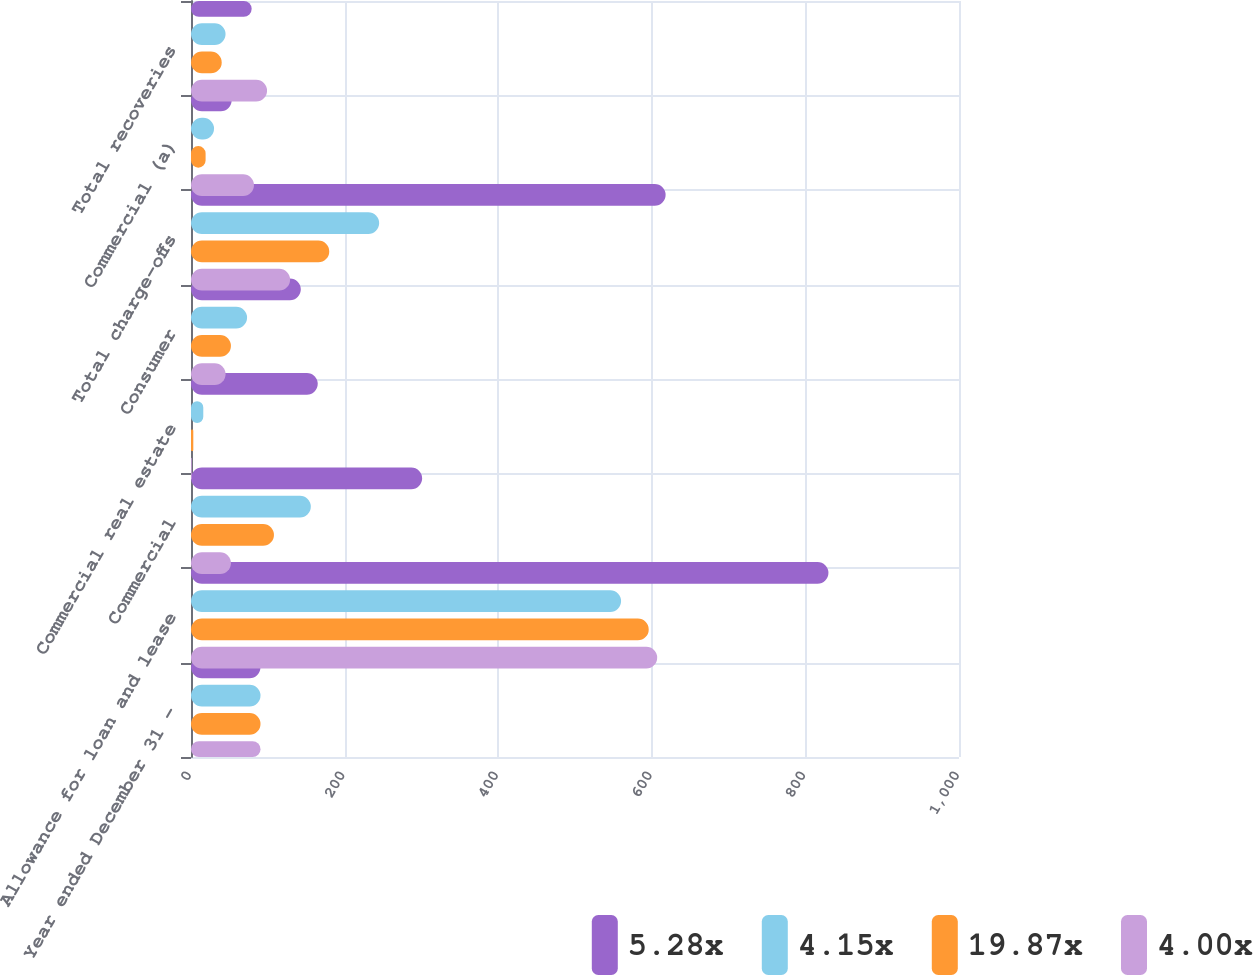<chart> <loc_0><loc_0><loc_500><loc_500><stacked_bar_chart><ecel><fcel>Year ended December 31 -<fcel>Allowance for loan and lease<fcel>Commercial<fcel>Commercial real estate<fcel>Consumer<fcel>Total charge-offs<fcel>Commercial (a)<fcel>Total recoveries<nl><fcel>5.28x<fcel>90.5<fcel>830<fcel>301<fcel>165<fcel>143<fcel>618<fcel>53<fcel>79<nl><fcel>4.15x<fcel>90.5<fcel>560<fcel>156<fcel>16<fcel>73<fcel>245<fcel>30<fcel>45<nl><fcel>19.87x<fcel>90.5<fcel>596<fcel>108<fcel>3<fcel>52<fcel>180<fcel>19<fcel>40<nl><fcel>4.00x<fcel>90.5<fcel>607<fcel>52<fcel>1<fcel>45<fcel>129<fcel>82<fcel>99<nl></chart> 